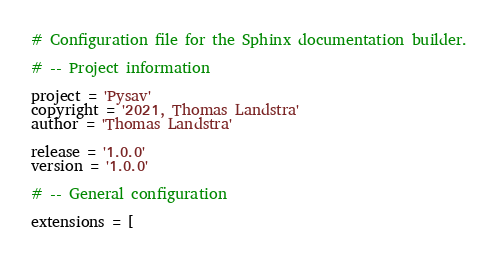<code> <loc_0><loc_0><loc_500><loc_500><_Python_># Configuration file for the Sphinx documentation builder.

# -- Project information

project = 'Pysav'
copyright = '2021, Thomas Landstra'
author = 'Thomas Landstra'

release = '1.0.0'
version = '1.0.0'

# -- General configuration

extensions = [</code> 